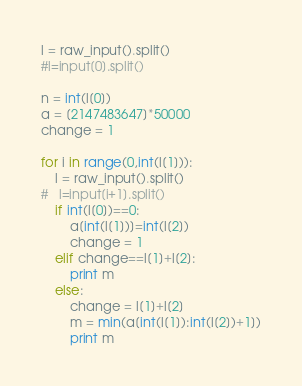Convert code to text. <code><loc_0><loc_0><loc_500><loc_500><_Python_>l = raw_input().split()
#l=input[0].split()

n = int(l[0])
a = [2147483647]*50000
change = 1

for i in range(0,int(l[1])):
	l = raw_input().split()
#	l=input[i+1].split()
	if int(l[0])==0:
		a[int(l[1])]=int(l[2])
		change = 1
	elif change==l[1]+l[2]:
		print m
	else:
		change = l[1]+l[2]
		m = min(a[int(l[1]):int(l[2])+1])
		print m</code> 